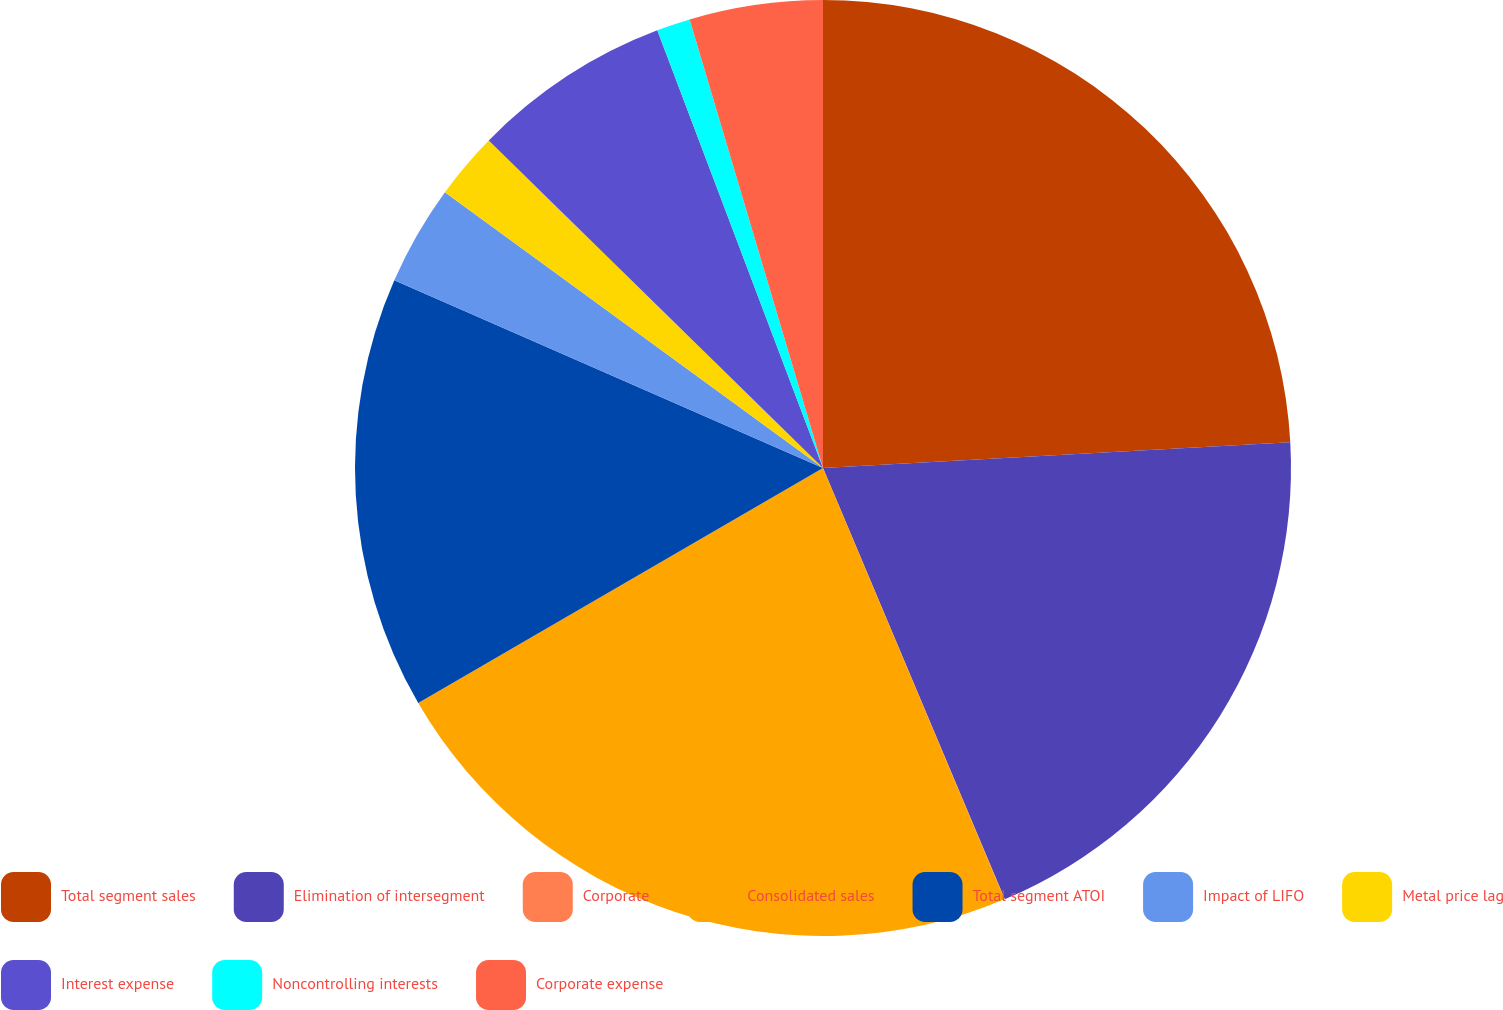Convert chart. <chart><loc_0><loc_0><loc_500><loc_500><pie_chart><fcel>Total segment sales<fcel>Elimination of intersegment<fcel>Corporate<fcel>Consolidated sales<fcel>Total segment ATOI<fcel>Impact of LIFO<fcel>Metal price lag<fcel>Interest expense<fcel>Noncontrolling interests<fcel>Corporate expense<nl><fcel>24.12%<fcel>19.53%<fcel>0.01%<fcel>22.97%<fcel>14.94%<fcel>3.46%<fcel>2.31%<fcel>6.9%<fcel>1.16%<fcel>4.6%<nl></chart> 